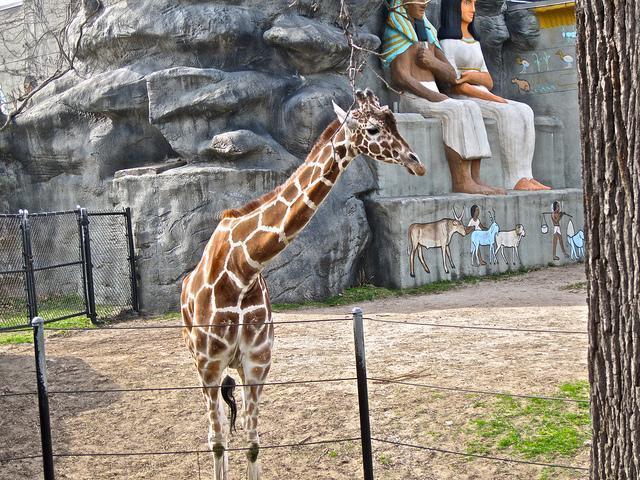Why are the fences lower than the giraffe's neck?
Indicate the correct response by choosing from the four available options to answer the question.
Options: Allow visibility, avoid entanglement, stop wildlife, filter light. Avoid entanglement. 